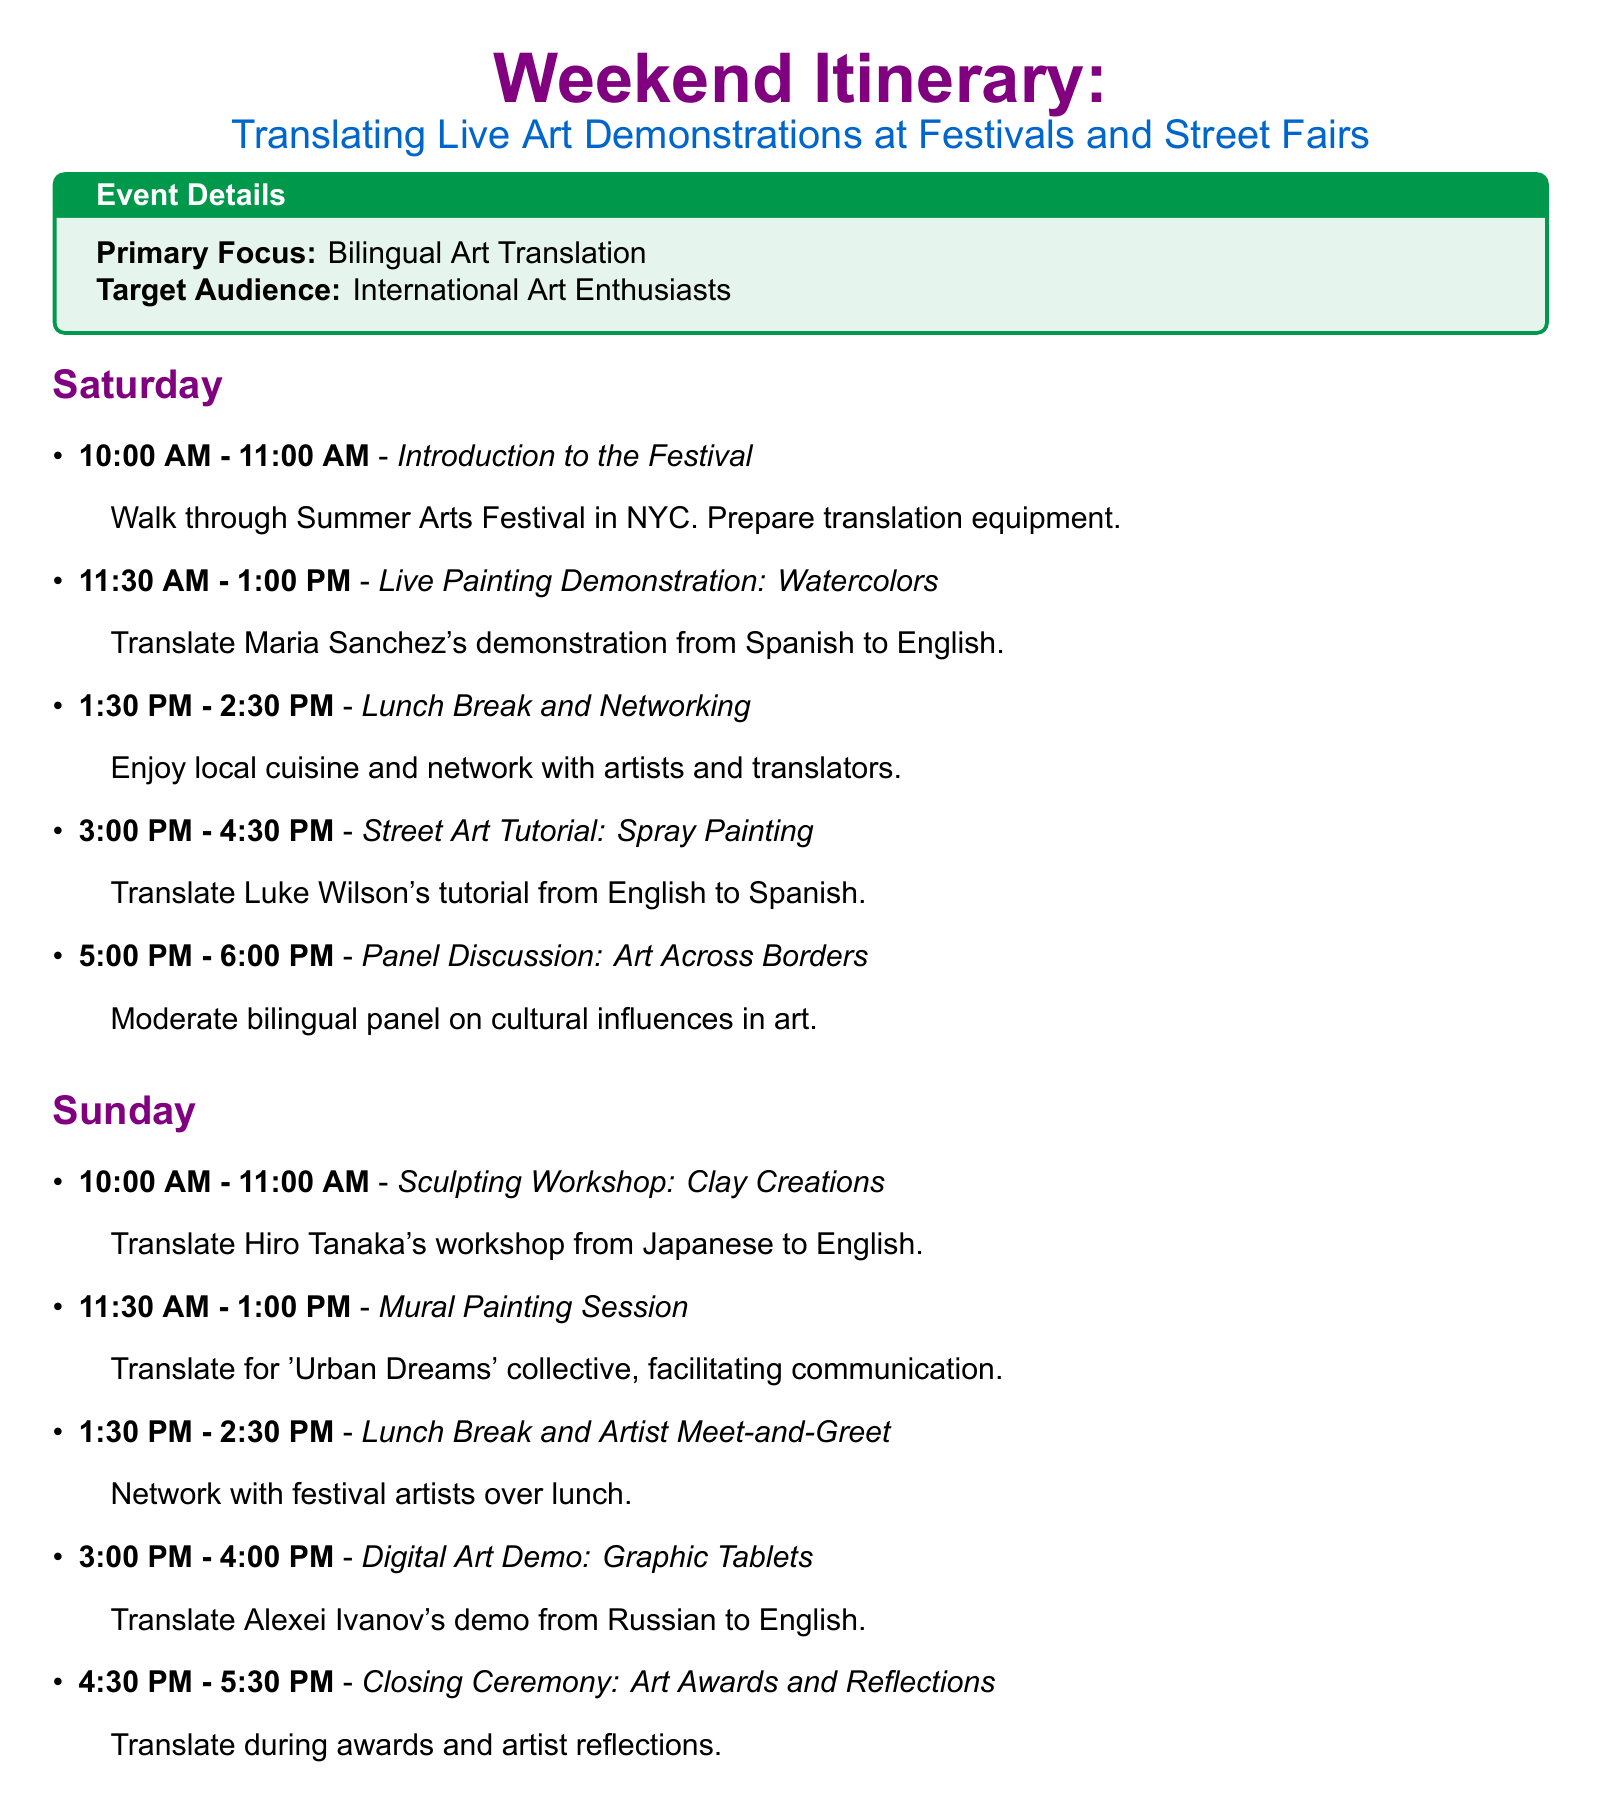What is the main focus of the weekend itinerary? The main focus of the itinerary is highlighted in the event details section, describing the primary activity.
Answer: Bilingual Art Translation What time does the Live Painting Demonstration start? The start time is specified in the schedule under Saturday activities.
Answer: 11:30 AM Who is the artist for the Watercolors demonstration? The artist's name is mentioned alongside the event in the live demonstration section.
Answer: Maria Sanchez What is the duration of the Sculpting Workshop? The duration is noted in the schedule for the Sunday activities.
Answer: 1 hour How many lunch breaks are scheduled over the weekend? The count is found in the Saturday and Sunday sections, identifying recurring lunch breaks.
Answer: 2 What type of event is occurring at 5:00 PM on Saturday? The type of event is specified along with the time in the itinerary's Saturday section.
Answer: Panel Discussion Which artist leads the tutorial on Spray Painting? The artist's name is included in the corresponding event under Saturday.
Answer: Luke Wilson What language will the Mural Painting Session require translation from? The need for translation is indicated in the description of the event in the Sunday activities.
Answer: English What is the name of the collective involved in the Mural Painting Session? The name of the collective is stated directly in the event description.
Answer: 'Urban Dreams' How is the weekend itinerary structured? The document is organized into two days with specific events listed under each day.
Answer: Daily Schedule 